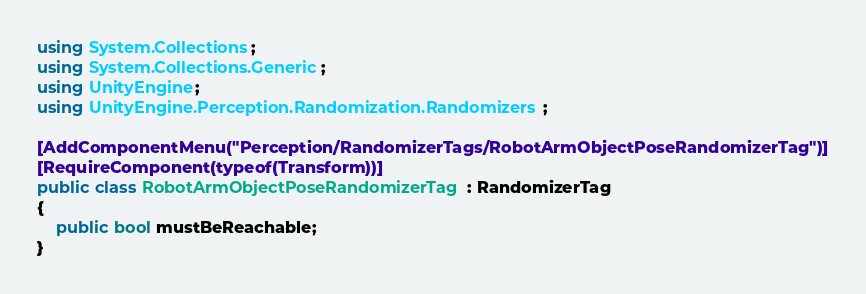<code> <loc_0><loc_0><loc_500><loc_500><_C#_>using System.Collections;
using System.Collections.Generic;
using UnityEngine;
using UnityEngine.Perception.Randomization.Randomizers;

[AddComponentMenu("Perception/RandomizerTags/RobotArmObjectPoseRandomizerTag")]
[RequireComponent(typeof(Transform))]
public class RobotArmObjectPoseRandomizerTag : RandomizerTag
{
    public bool mustBeReachable;
}
</code> 